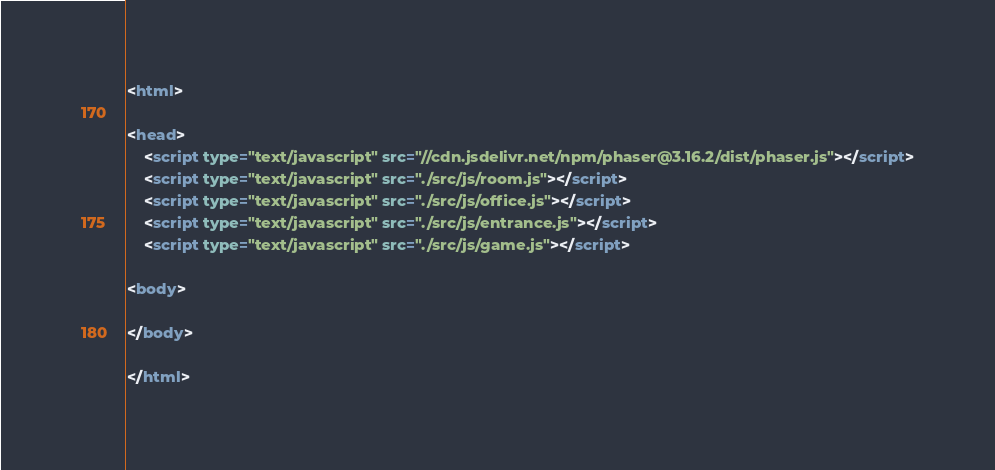<code> <loc_0><loc_0><loc_500><loc_500><_HTML_><html>

<head>
    <script type="text/javascript" src="//cdn.jsdelivr.net/npm/phaser@3.16.2/dist/phaser.js"></script>
    <script type="text/javascript" src="./src/js/room.js"></script>
    <script type="text/javascript" src="./src/js/office.js"></script>
    <script type="text/javascript" src="./src/js/entrance.js"></script>
    <script type="text/javascript" src="./src/js/game.js"></script>

<body>

</body>

</html></code> 